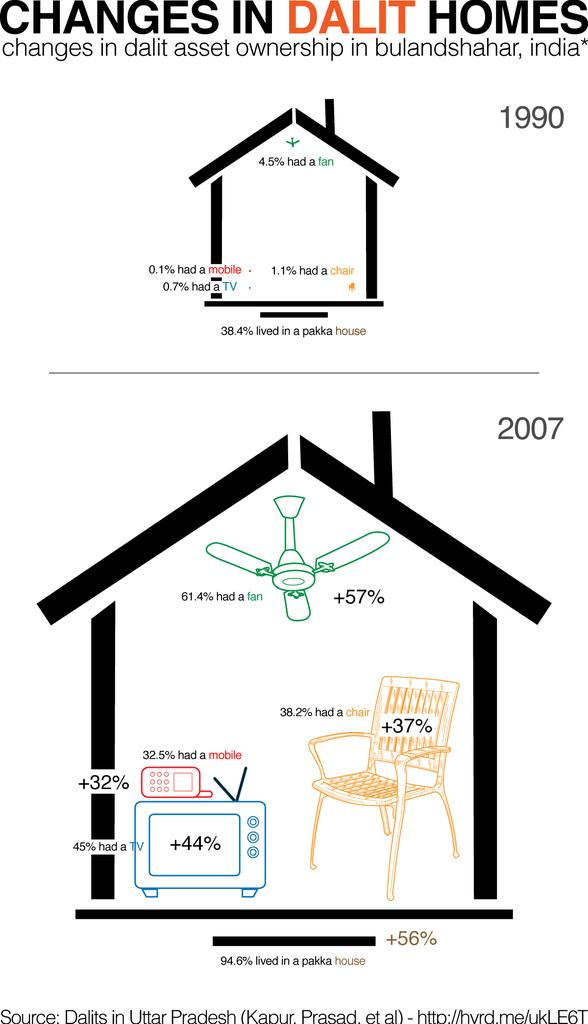What is depicted on the poster in the image? The poster contains images of houses. Are there any other objects or elements on the poster besides the houses? Yes, there is a fan, a chair, a radio, a mobile phone, and text on the poster. Can you see a tiger in the image? No, there is no tiger present in the image. What type of appliance is shown on the poster? There is no appliance depicted on the poster; it features images of houses, a fan, a chair, a radio, a mobile phone, and text. 